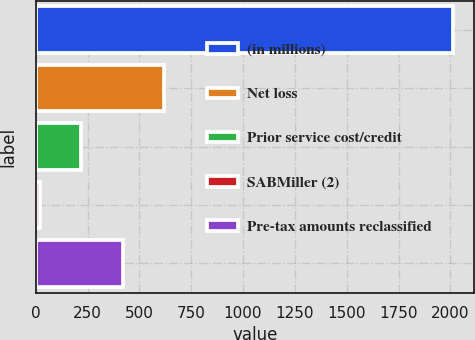Convert chart. <chart><loc_0><loc_0><loc_500><loc_500><bar_chart><fcel>(in millions)<fcel>Net loss<fcel>Prior service cost/credit<fcel>SABMiller (2)<fcel>Pre-tax amounts reclassified<nl><fcel>2015<fcel>619.2<fcel>220.4<fcel>21<fcel>419.8<nl></chart> 